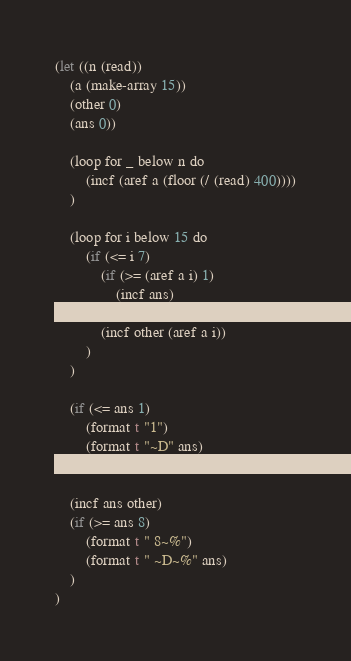Convert code to text. <code><loc_0><loc_0><loc_500><loc_500><_Lisp_>(let ((n (read))
    (a (make-array 15))
    (other 0)
    (ans 0))

    (loop for _ below n do
        (incf (aref a (floor (/ (read) 400))))
    )

    (loop for i below 15 do
        (if (<= i 7)
            (if (>= (aref a i) 1)
                (incf ans)
            )
            (incf other (aref a i))
        )
    )

    (if (<= ans 1)
        (format t "1")
        (format t "~D" ans)
    )

    (incf ans other)
    (if (>= ans 8)
        (format t " 8~%")
        (format t " ~D~%" ans)
    )
)</code> 